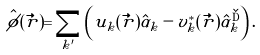<formula> <loc_0><loc_0><loc_500><loc_500>\hat { \phi } ( \vec { r } ) = \sum _ { k ^ { \prime } } \left ( u _ { k } ( \vec { r } ) \hat { \alpha } _ { k } - v ^ { * } _ { k } ( \vec { r } ) \hat { \alpha } _ { k } ^ { \dag } \right ) .</formula> 